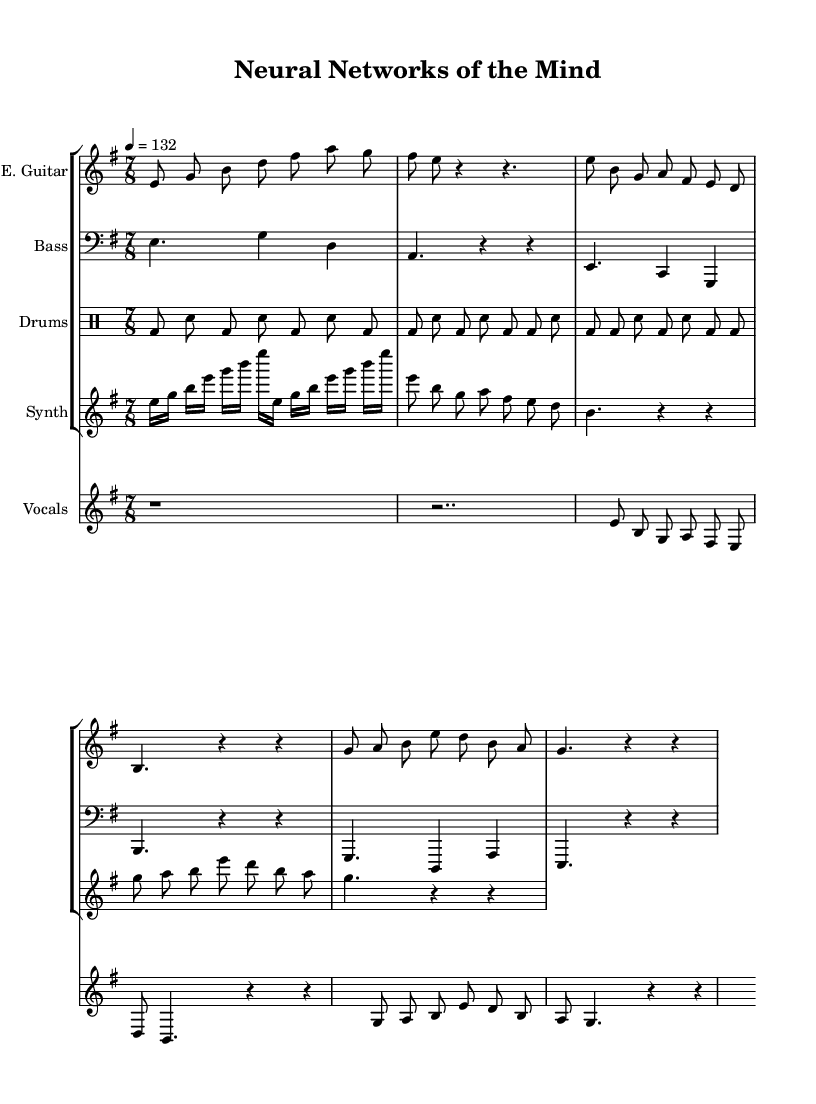What is the key signature of this music? The key signature is indicated at the beginning of the score. In this case, it is E minor, which has one sharp (F#).
Answer: E minor What is the time signature of this piece? The time signature is displayed directly after the key signature. It reads 7/8, meaning there are seven eighth notes in each measure.
Answer: 7/8 What is the tempo marking for the piece? The tempo marking appears next to the time signature and indicates the speed of the music. It states "4 = 132," which means there are 132 beats per minute, with the quarter note designated as the beat.
Answer: 132 How many measures are in the intro section of the electric guitar part? By counting the number of grouped notes in the electric guitar section marked as Intro, we see there are two measures containing the notes.
Answer: 2 How does the vocal melody relate to the verse and chorus structure? The vocal part consists of distinct sections labeled as Verse and Chorus. The Verse has the lyrical line "Neural networks in our minds," while the Chorus has "Blending thoughts with silicon." This shows thematic development in the lyrics, transitioning from the verse's exploration to the chorus's summary of blending thoughts with technology.
Answer: Verse and Chorus What instruments are included in this arrangement? The score clearly lists the instruments used in the arrangement in the staff groups. These instruments include the Electric Guitar, Bass, Drums, Synthesizer, and Vocals.
Answer: Electric Guitar, Bass, Drums, Synthesizer, Vocals 